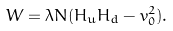Convert formula to latex. <formula><loc_0><loc_0><loc_500><loc_500>W = \lambda N ( H _ { u } H _ { d } - v _ { 0 } ^ { 2 } ) .</formula> 